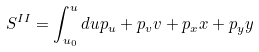<formula> <loc_0><loc_0><loc_500><loc_500>S ^ { I I } = \int ^ { u } _ { u _ { 0 } } d u p _ { u } + p _ { v } v + p _ { x } x + p _ { y } y</formula> 